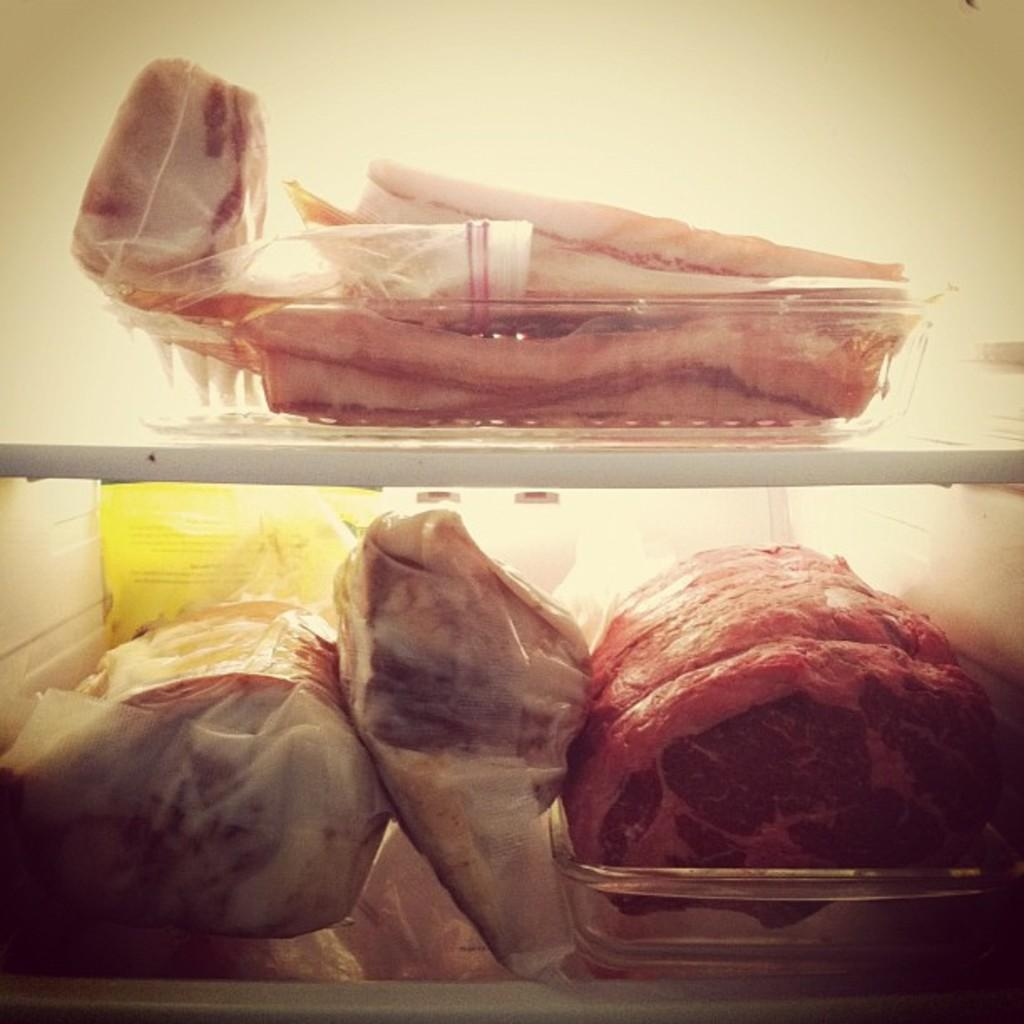What is located in the foreground of the image? There are baskets in the foreground of the image. What is inside the baskets? The baskets contain meat. How are the baskets arranged in the image? The baskets are placed on shelves. Can you describe any other objects visible in the image? There are additional objects visible in the image, but their specific details are not mentioned in the provided facts. What type of boot is being used to provide shade for the baskets in the image? There is no boot or shade present in the image; it features baskets containing meat placed on shelves. 